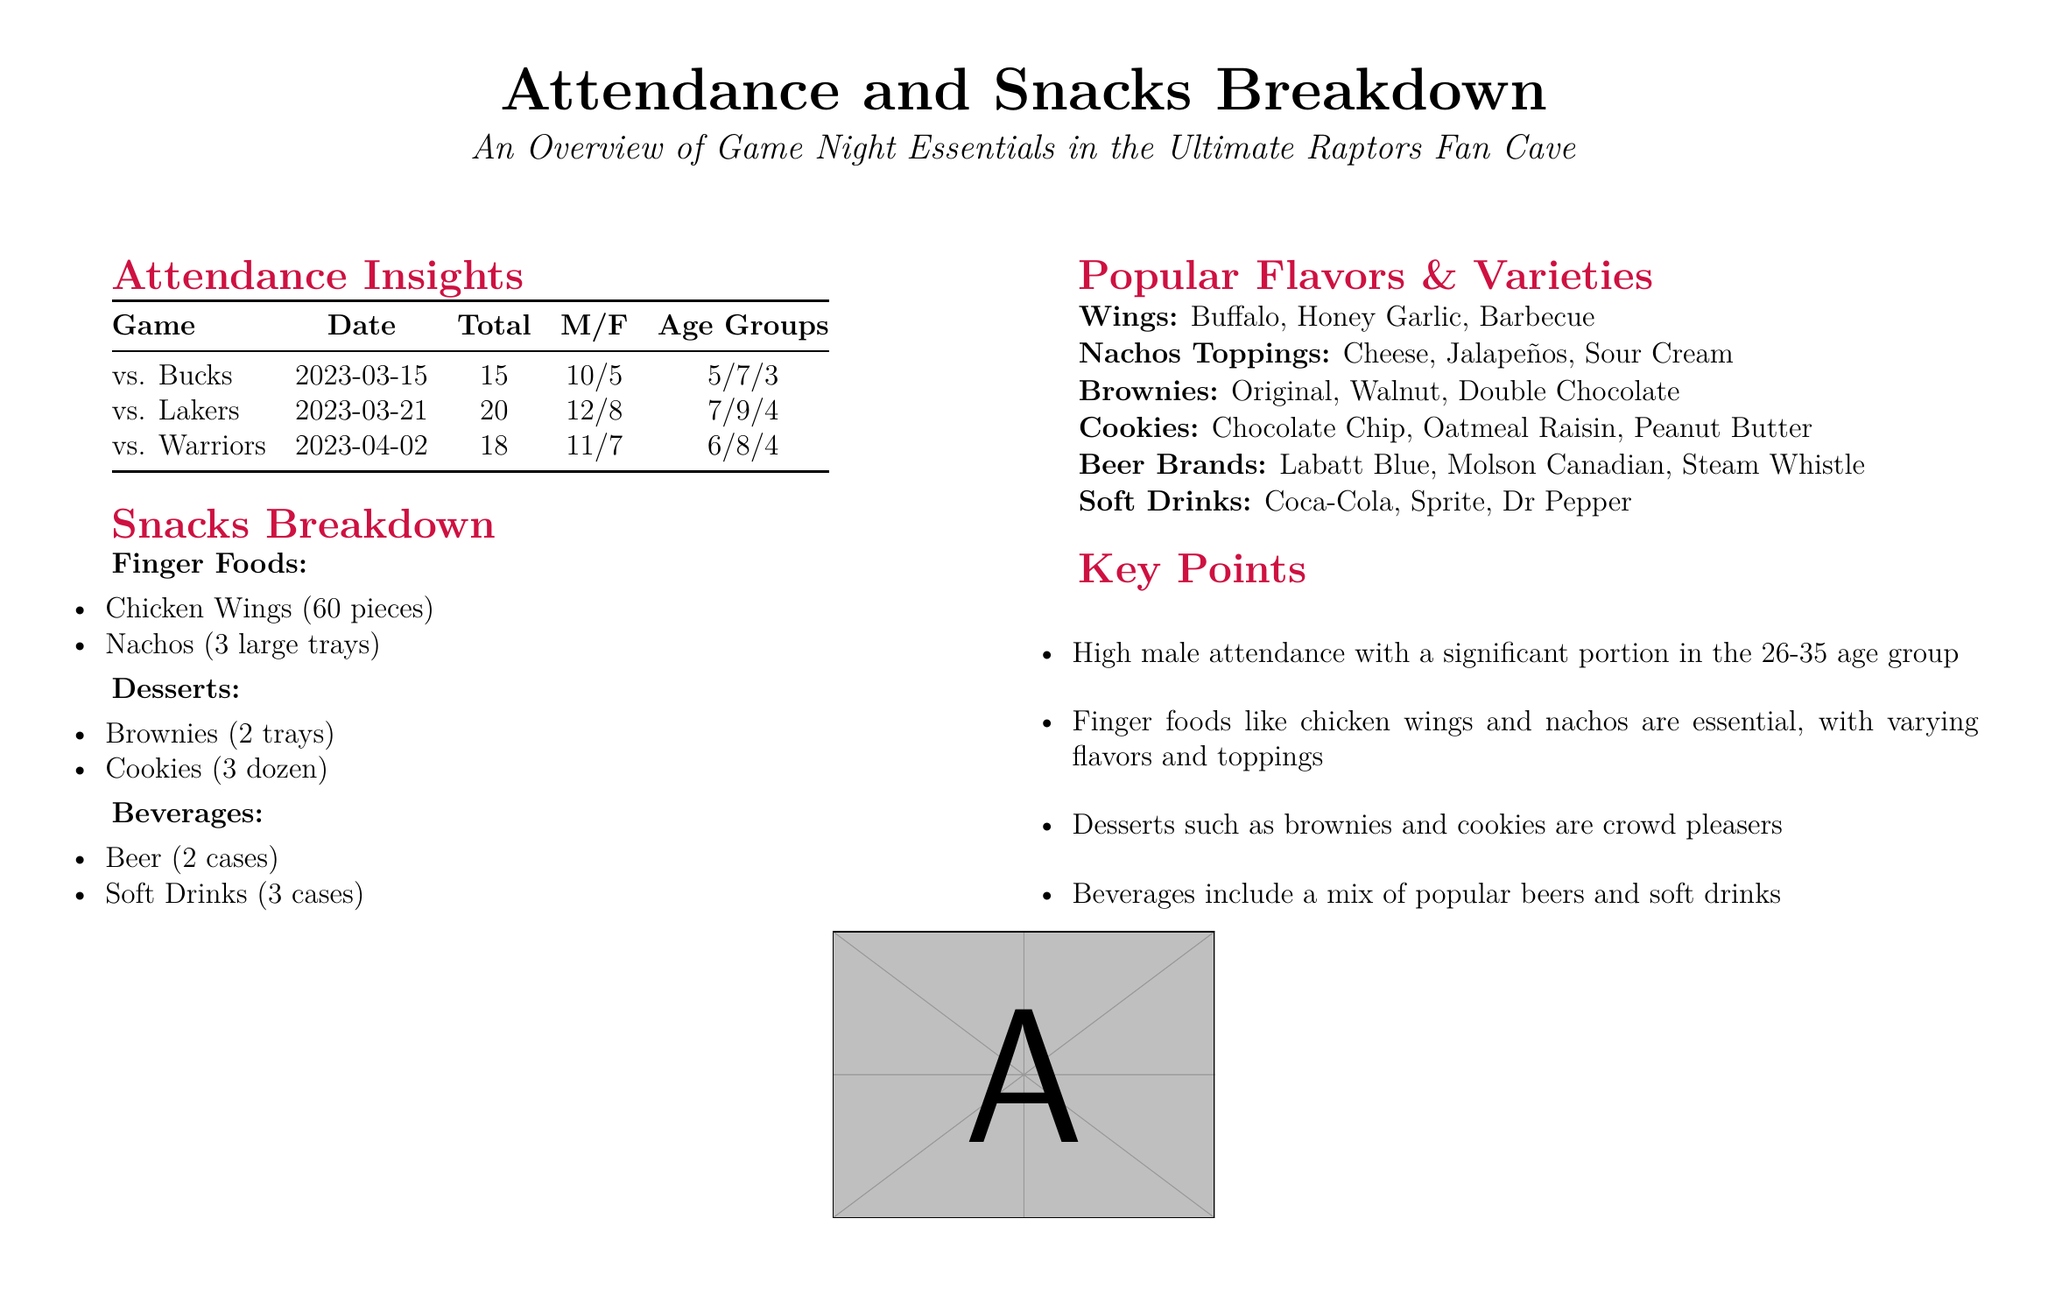What was the date of the game against the Lakers? The specific date of the game against the Lakers is found in the document under Attendance Insights.
Answer: 2023-03-21 How many total attendees were at the game against the Warriors? The total number of attendees at the game against the Warriors is listed in the Attendance Insights section of the document.
Answer: 18 What are the finger foods mentioned in the snacks breakdown? The finger foods are detailed in the Snacks Breakdown section, listing specific items provided.
Answer: Chicken Wings, Nachos Which age group had a significant portion of attendees? The document highlights the age groups in the Attendance Insights section, indicating that one age group was prominent.
Answer: 26-35 How many types of cookies were provided? The number of cookie varieties is specified in the Popular Flavors & Varieties section of the document.
Answer: 3 What beverage cases were provided for the watch parties? The beverages provided are detailed in the Snacks Breakdown section of the document, specifically the types of drinks and their counts.
Answer: 2 cases of Beer, 3 cases of Soft Drinks Which dessert type is listed in the document? The desserts provided include specific items mentioned in the Snacks Breakdown section.
Answer: Brownies What is the flavor of the wings mentioned in the document? The Popular Flavors & Varieties section specifies different flavors available for the wings.
Answer: Buffalo, Honey Garlic, Barbecue 